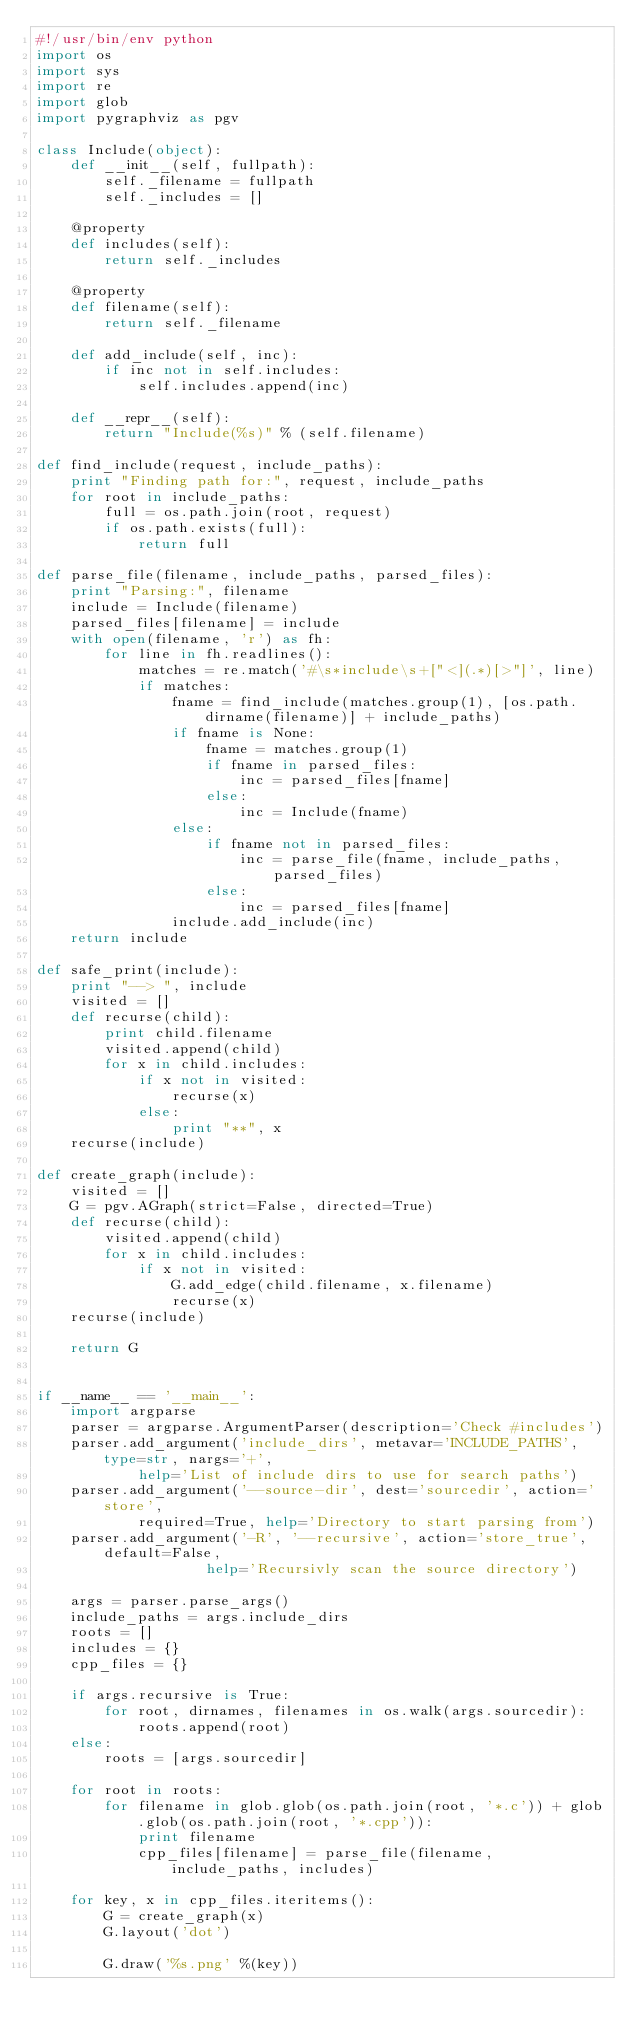Convert code to text. <code><loc_0><loc_0><loc_500><loc_500><_Python_>#!/usr/bin/env python
import os
import sys
import re
import glob
import pygraphviz as pgv

class Include(object):
	def __init__(self, fullpath):
		self._filename = fullpath
		self._includes = []

	@property
	def includes(self):
		return self._includes
	
	@property
	def filename(self):
		return self._filename
	
	def add_include(self, inc):
		if inc not in self.includes:
			self.includes.append(inc)

	def __repr__(self):
		return "Include(%s)" % (self.filename)

def find_include(request, include_paths):
	print "Finding path for:", request, include_paths
	for root in include_paths:
		full = os.path.join(root, request)
		if os.path.exists(full):
			return full
	
def parse_file(filename, include_paths, parsed_files):
	print "Parsing:", filename
	include = Include(filename)
	parsed_files[filename] = include
	with open(filename, 'r') as fh:
		for line in fh.readlines():
			matches = re.match('#\s*include\s+["<](.*)[>"]', line)
			if matches:
				fname = find_include(matches.group(1), [os.path.dirname(filename)] + include_paths)
				if fname is None:
					fname = matches.group(1)
					if fname in parsed_files:
						inc = parsed_files[fname]
					else:
						inc = Include(fname)
				else:
					if fname not in parsed_files:
						inc = parse_file(fname, include_paths, parsed_files)
					else:
						inc = parsed_files[fname]
				include.add_include(inc)
	return include

def safe_print(include):
	print "--> ", include
	visited = []
	def recurse(child):
		print child.filename
		visited.append(child)
		for x in child.includes:
			if x not in visited:
				recurse(x)
			else:
				print "**", x
	recurse(include)

def create_graph(include):
	visited = []
	G = pgv.AGraph(strict=False, directed=True)
	def recurse(child):
		visited.append(child)
		for x in child.includes:
			if x not in visited:
				G.add_edge(child.filename, x.filename)
				recurse(x)
	recurse(include)

	return G


if __name__ == '__main__':
	import argparse
	parser = argparse.ArgumentParser(description='Check #includes')
	parser.add_argument('include_dirs', metavar='INCLUDE_PATHS', type=str, nargs='+',
			help='List of include dirs to use for search paths')
	parser.add_argument('--source-dir', dest='sourcedir', action='store',
			required=True, help='Directory to start parsing from')
	parser.add_argument('-R', '--recursive', action='store_true', default=False,
                    help='Recursivly scan the source directory')

	args = parser.parse_args()
	include_paths = args.include_dirs
	roots = []
	includes = {}
	cpp_files = {}

	if args.recursive is True:
		for root, dirnames, filenames in os.walk(args.sourcedir):
			roots.append(root)
	else:
		roots = [args.sourcedir]

	for root in roots:
		for filename in glob.glob(os.path.join(root, '*.c')) + glob.glob(os.path.join(root, '*.cpp')):
			print filename
			cpp_files[filename] = parse_file(filename, include_paths, includes)

	for key, x in cpp_files.iteritems():
		G = create_graph(x)
		G.layout('dot')
		
		G.draw('%s.png' %(key))
</code> 